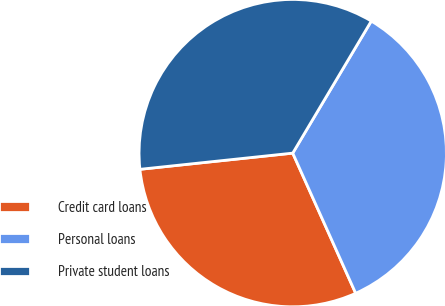<chart> <loc_0><loc_0><loc_500><loc_500><pie_chart><fcel>Credit card loans<fcel>Personal loans<fcel>Private student loans<nl><fcel>30.04%<fcel>34.74%<fcel>35.22%<nl></chart> 